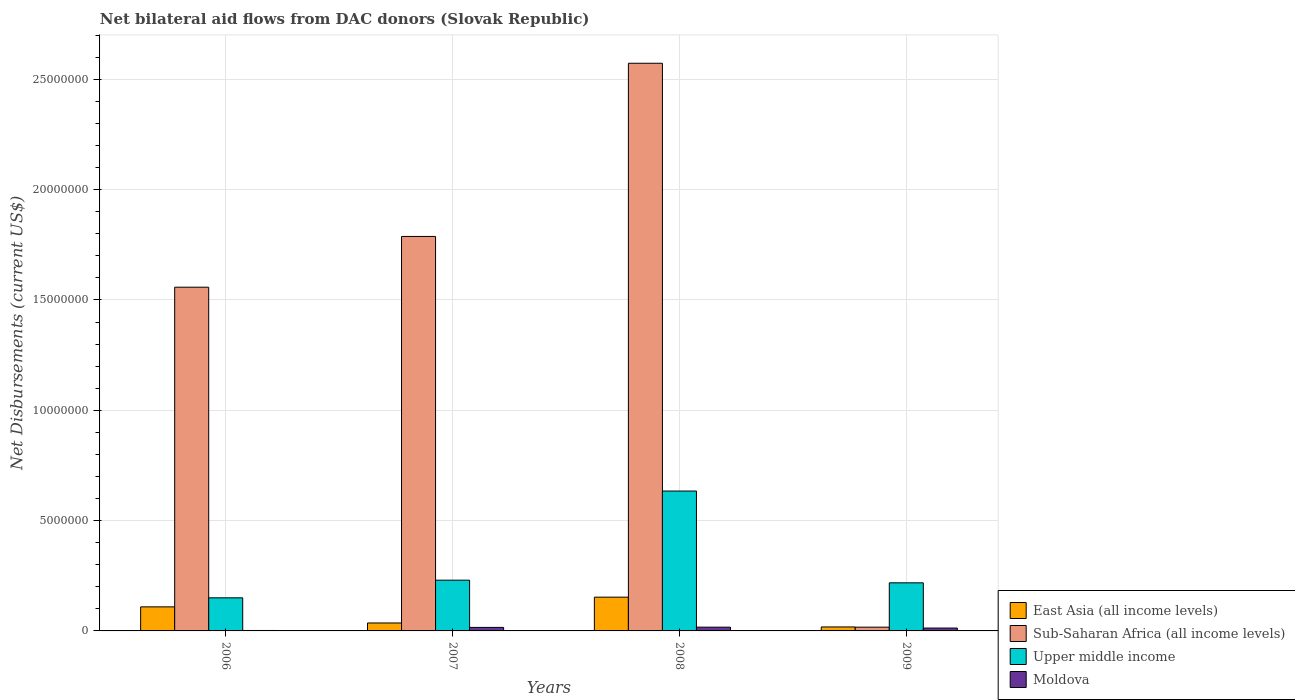How many different coloured bars are there?
Your answer should be very brief. 4. What is the label of the 2nd group of bars from the left?
Your answer should be compact. 2007. What is the net bilateral aid flows in Moldova in 2008?
Your answer should be compact. 1.70e+05. Across all years, what is the maximum net bilateral aid flows in Upper middle income?
Your response must be concise. 6.34e+06. Across all years, what is the minimum net bilateral aid flows in Sub-Saharan Africa (all income levels)?
Offer a very short reply. 1.70e+05. What is the difference between the net bilateral aid flows in Sub-Saharan Africa (all income levels) in 2006 and that in 2007?
Provide a succinct answer. -2.30e+06. What is the difference between the net bilateral aid flows in Sub-Saharan Africa (all income levels) in 2008 and the net bilateral aid flows in Upper middle income in 2006?
Offer a terse response. 2.42e+07. What is the average net bilateral aid flows in Upper middle income per year?
Keep it short and to the point. 3.08e+06. In the year 2006, what is the difference between the net bilateral aid flows in Sub-Saharan Africa (all income levels) and net bilateral aid flows in Moldova?
Provide a short and direct response. 1.56e+07. In how many years, is the net bilateral aid flows in Upper middle income greater than 23000000 US$?
Keep it short and to the point. 0. What is the ratio of the net bilateral aid flows in Upper middle income in 2006 to that in 2008?
Provide a succinct answer. 0.24. Is the net bilateral aid flows in East Asia (all income levels) in 2007 less than that in 2008?
Offer a very short reply. Yes. What is the difference between the highest and the second highest net bilateral aid flows in Upper middle income?
Your answer should be compact. 4.04e+06. What is the difference between the highest and the lowest net bilateral aid flows in Sub-Saharan Africa (all income levels)?
Your answer should be compact. 2.56e+07. In how many years, is the net bilateral aid flows in Upper middle income greater than the average net bilateral aid flows in Upper middle income taken over all years?
Your answer should be very brief. 1. Is the sum of the net bilateral aid flows in Moldova in 2007 and 2009 greater than the maximum net bilateral aid flows in Sub-Saharan Africa (all income levels) across all years?
Keep it short and to the point. No. What does the 4th bar from the left in 2006 represents?
Give a very brief answer. Moldova. What does the 1st bar from the right in 2007 represents?
Your answer should be compact. Moldova. What is the difference between two consecutive major ticks on the Y-axis?
Your answer should be very brief. 5.00e+06. Does the graph contain grids?
Your answer should be compact. Yes. How many legend labels are there?
Provide a succinct answer. 4. How are the legend labels stacked?
Ensure brevity in your answer.  Vertical. What is the title of the graph?
Offer a very short reply. Net bilateral aid flows from DAC donors (Slovak Republic). Does "Barbados" appear as one of the legend labels in the graph?
Provide a short and direct response. No. What is the label or title of the Y-axis?
Your answer should be very brief. Net Disbursements (current US$). What is the Net Disbursements (current US$) in East Asia (all income levels) in 2006?
Give a very brief answer. 1.09e+06. What is the Net Disbursements (current US$) in Sub-Saharan Africa (all income levels) in 2006?
Your answer should be compact. 1.56e+07. What is the Net Disbursements (current US$) in Upper middle income in 2006?
Ensure brevity in your answer.  1.50e+06. What is the Net Disbursements (current US$) of East Asia (all income levels) in 2007?
Your answer should be very brief. 3.60e+05. What is the Net Disbursements (current US$) in Sub-Saharan Africa (all income levels) in 2007?
Give a very brief answer. 1.79e+07. What is the Net Disbursements (current US$) of Upper middle income in 2007?
Offer a very short reply. 2.30e+06. What is the Net Disbursements (current US$) of Moldova in 2007?
Your response must be concise. 1.60e+05. What is the Net Disbursements (current US$) of East Asia (all income levels) in 2008?
Your answer should be very brief. 1.53e+06. What is the Net Disbursements (current US$) of Sub-Saharan Africa (all income levels) in 2008?
Offer a very short reply. 2.57e+07. What is the Net Disbursements (current US$) of Upper middle income in 2008?
Provide a short and direct response. 6.34e+06. What is the Net Disbursements (current US$) in Moldova in 2008?
Your answer should be very brief. 1.70e+05. What is the Net Disbursements (current US$) in Upper middle income in 2009?
Offer a terse response. 2.18e+06. What is the Net Disbursements (current US$) in Moldova in 2009?
Offer a very short reply. 1.30e+05. Across all years, what is the maximum Net Disbursements (current US$) of East Asia (all income levels)?
Provide a short and direct response. 1.53e+06. Across all years, what is the maximum Net Disbursements (current US$) in Sub-Saharan Africa (all income levels)?
Ensure brevity in your answer.  2.57e+07. Across all years, what is the maximum Net Disbursements (current US$) of Upper middle income?
Give a very brief answer. 6.34e+06. Across all years, what is the maximum Net Disbursements (current US$) in Moldova?
Provide a succinct answer. 1.70e+05. Across all years, what is the minimum Net Disbursements (current US$) in Sub-Saharan Africa (all income levels)?
Provide a succinct answer. 1.70e+05. Across all years, what is the minimum Net Disbursements (current US$) in Upper middle income?
Make the answer very short. 1.50e+06. Across all years, what is the minimum Net Disbursements (current US$) of Moldova?
Offer a terse response. 2.00e+04. What is the total Net Disbursements (current US$) in East Asia (all income levels) in the graph?
Keep it short and to the point. 3.16e+06. What is the total Net Disbursements (current US$) in Sub-Saharan Africa (all income levels) in the graph?
Give a very brief answer. 5.94e+07. What is the total Net Disbursements (current US$) in Upper middle income in the graph?
Make the answer very short. 1.23e+07. What is the difference between the Net Disbursements (current US$) in East Asia (all income levels) in 2006 and that in 2007?
Your answer should be very brief. 7.30e+05. What is the difference between the Net Disbursements (current US$) of Sub-Saharan Africa (all income levels) in 2006 and that in 2007?
Provide a succinct answer. -2.30e+06. What is the difference between the Net Disbursements (current US$) in Upper middle income in 2006 and that in 2007?
Provide a succinct answer. -8.00e+05. What is the difference between the Net Disbursements (current US$) in East Asia (all income levels) in 2006 and that in 2008?
Your answer should be very brief. -4.40e+05. What is the difference between the Net Disbursements (current US$) in Sub-Saharan Africa (all income levels) in 2006 and that in 2008?
Provide a short and direct response. -1.02e+07. What is the difference between the Net Disbursements (current US$) of Upper middle income in 2006 and that in 2008?
Provide a succinct answer. -4.84e+06. What is the difference between the Net Disbursements (current US$) in East Asia (all income levels) in 2006 and that in 2009?
Your response must be concise. 9.10e+05. What is the difference between the Net Disbursements (current US$) of Sub-Saharan Africa (all income levels) in 2006 and that in 2009?
Ensure brevity in your answer.  1.54e+07. What is the difference between the Net Disbursements (current US$) in Upper middle income in 2006 and that in 2009?
Offer a terse response. -6.80e+05. What is the difference between the Net Disbursements (current US$) in East Asia (all income levels) in 2007 and that in 2008?
Keep it short and to the point. -1.17e+06. What is the difference between the Net Disbursements (current US$) in Sub-Saharan Africa (all income levels) in 2007 and that in 2008?
Make the answer very short. -7.85e+06. What is the difference between the Net Disbursements (current US$) of Upper middle income in 2007 and that in 2008?
Provide a succinct answer. -4.04e+06. What is the difference between the Net Disbursements (current US$) in East Asia (all income levels) in 2007 and that in 2009?
Provide a succinct answer. 1.80e+05. What is the difference between the Net Disbursements (current US$) in Sub-Saharan Africa (all income levels) in 2007 and that in 2009?
Offer a terse response. 1.77e+07. What is the difference between the Net Disbursements (current US$) of Upper middle income in 2007 and that in 2009?
Your answer should be compact. 1.20e+05. What is the difference between the Net Disbursements (current US$) of East Asia (all income levels) in 2008 and that in 2009?
Keep it short and to the point. 1.35e+06. What is the difference between the Net Disbursements (current US$) of Sub-Saharan Africa (all income levels) in 2008 and that in 2009?
Give a very brief answer. 2.56e+07. What is the difference between the Net Disbursements (current US$) of Upper middle income in 2008 and that in 2009?
Make the answer very short. 4.16e+06. What is the difference between the Net Disbursements (current US$) of Moldova in 2008 and that in 2009?
Provide a short and direct response. 4.00e+04. What is the difference between the Net Disbursements (current US$) of East Asia (all income levels) in 2006 and the Net Disbursements (current US$) of Sub-Saharan Africa (all income levels) in 2007?
Provide a short and direct response. -1.68e+07. What is the difference between the Net Disbursements (current US$) of East Asia (all income levels) in 2006 and the Net Disbursements (current US$) of Upper middle income in 2007?
Give a very brief answer. -1.21e+06. What is the difference between the Net Disbursements (current US$) of East Asia (all income levels) in 2006 and the Net Disbursements (current US$) of Moldova in 2007?
Ensure brevity in your answer.  9.30e+05. What is the difference between the Net Disbursements (current US$) in Sub-Saharan Africa (all income levels) in 2006 and the Net Disbursements (current US$) in Upper middle income in 2007?
Your answer should be very brief. 1.33e+07. What is the difference between the Net Disbursements (current US$) of Sub-Saharan Africa (all income levels) in 2006 and the Net Disbursements (current US$) of Moldova in 2007?
Keep it short and to the point. 1.54e+07. What is the difference between the Net Disbursements (current US$) in Upper middle income in 2006 and the Net Disbursements (current US$) in Moldova in 2007?
Your response must be concise. 1.34e+06. What is the difference between the Net Disbursements (current US$) of East Asia (all income levels) in 2006 and the Net Disbursements (current US$) of Sub-Saharan Africa (all income levels) in 2008?
Your response must be concise. -2.46e+07. What is the difference between the Net Disbursements (current US$) of East Asia (all income levels) in 2006 and the Net Disbursements (current US$) of Upper middle income in 2008?
Ensure brevity in your answer.  -5.25e+06. What is the difference between the Net Disbursements (current US$) in East Asia (all income levels) in 2006 and the Net Disbursements (current US$) in Moldova in 2008?
Provide a short and direct response. 9.20e+05. What is the difference between the Net Disbursements (current US$) of Sub-Saharan Africa (all income levels) in 2006 and the Net Disbursements (current US$) of Upper middle income in 2008?
Provide a short and direct response. 9.24e+06. What is the difference between the Net Disbursements (current US$) of Sub-Saharan Africa (all income levels) in 2006 and the Net Disbursements (current US$) of Moldova in 2008?
Your response must be concise. 1.54e+07. What is the difference between the Net Disbursements (current US$) of Upper middle income in 2006 and the Net Disbursements (current US$) of Moldova in 2008?
Provide a short and direct response. 1.33e+06. What is the difference between the Net Disbursements (current US$) of East Asia (all income levels) in 2006 and the Net Disbursements (current US$) of Sub-Saharan Africa (all income levels) in 2009?
Your response must be concise. 9.20e+05. What is the difference between the Net Disbursements (current US$) in East Asia (all income levels) in 2006 and the Net Disbursements (current US$) in Upper middle income in 2009?
Make the answer very short. -1.09e+06. What is the difference between the Net Disbursements (current US$) of East Asia (all income levels) in 2006 and the Net Disbursements (current US$) of Moldova in 2009?
Your response must be concise. 9.60e+05. What is the difference between the Net Disbursements (current US$) of Sub-Saharan Africa (all income levels) in 2006 and the Net Disbursements (current US$) of Upper middle income in 2009?
Provide a short and direct response. 1.34e+07. What is the difference between the Net Disbursements (current US$) in Sub-Saharan Africa (all income levels) in 2006 and the Net Disbursements (current US$) in Moldova in 2009?
Your answer should be compact. 1.54e+07. What is the difference between the Net Disbursements (current US$) of Upper middle income in 2006 and the Net Disbursements (current US$) of Moldova in 2009?
Provide a succinct answer. 1.37e+06. What is the difference between the Net Disbursements (current US$) of East Asia (all income levels) in 2007 and the Net Disbursements (current US$) of Sub-Saharan Africa (all income levels) in 2008?
Offer a very short reply. -2.54e+07. What is the difference between the Net Disbursements (current US$) of East Asia (all income levels) in 2007 and the Net Disbursements (current US$) of Upper middle income in 2008?
Offer a very short reply. -5.98e+06. What is the difference between the Net Disbursements (current US$) of Sub-Saharan Africa (all income levels) in 2007 and the Net Disbursements (current US$) of Upper middle income in 2008?
Your answer should be very brief. 1.15e+07. What is the difference between the Net Disbursements (current US$) in Sub-Saharan Africa (all income levels) in 2007 and the Net Disbursements (current US$) in Moldova in 2008?
Your answer should be compact. 1.77e+07. What is the difference between the Net Disbursements (current US$) of Upper middle income in 2007 and the Net Disbursements (current US$) of Moldova in 2008?
Provide a succinct answer. 2.13e+06. What is the difference between the Net Disbursements (current US$) of East Asia (all income levels) in 2007 and the Net Disbursements (current US$) of Sub-Saharan Africa (all income levels) in 2009?
Your response must be concise. 1.90e+05. What is the difference between the Net Disbursements (current US$) of East Asia (all income levels) in 2007 and the Net Disbursements (current US$) of Upper middle income in 2009?
Keep it short and to the point. -1.82e+06. What is the difference between the Net Disbursements (current US$) in East Asia (all income levels) in 2007 and the Net Disbursements (current US$) in Moldova in 2009?
Offer a very short reply. 2.30e+05. What is the difference between the Net Disbursements (current US$) in Sub-Saharan Africa (all income levels) in 2007 and the Net Disbursements (current US$) in Upper middle income in 2009?
Provide a short and direct response. 1.57e+07. What is the difference between the Net Disbursements (current US$) of Sub-Saharan Africa (all income levels) in 2007 and the Net Disbursements (current US$) of Moldova in 2009?
Offer a very short reply. 1.78e+07. What is the difference between the Net Disbursements (current US$) in Upper middle income in 2007 and the Net Disbursements (current US$) in Moldova in 2009?
Ensure brevity in your answer.  2.17e+06. What is the difference between the Net Disbursements (current US$) of East Asia (all income levels) in 2008 and the Net Disbursements (current US$) of Sub-Saharan Africa (all income levels) in 2009?
Ensure brevity in your answer.  1.36e+06. What is the difference between the Net Disbursements (current US$) in East Asia (all income levels) in 2008 and the Net Disbursements (current US$) in Upper middle income in 2009?
Provide a succinct answer. -6.50e+05. What is the difference between the Net Disbursements (current US$) in East Asia (all income levels) in 2008 and the Net Disbursements (current US$) in Moldova in 2009?
Make the answer very short. 1.40e+06. What is the difference between the Net Disbursements (current US$) in Sub-Saharan Africa (all income levels) in 2008 and the Net Disbursements (current US$) in Upper middle income in 2009?
Provide a short and direct response. 2.36e+07. What is the difference between the Net Disbursements (current US$) in Sub-Saharan Africa (all income levels) in 2008 and the Net Disbursements (current US$) in Moldova in 2009?
Provide a succinct answer. 2.56e+07. What is the difference between the Net Disbursements (current US$) in Upper middle income in 2008 and the Net Disbursements (current US$) in Moldova in 2009?
Your answer should be very brief. 6.21e+06. What is the average Net Disbursements (current US$) of East Asia (all income levels) per year?
Your answer should be compact. 7.90e+05. What is the average Net Disbursements (current US$) of Sub-Saharan Africa (all income levels) per year?
Provide a short and direct response. 1.48e+07. What is the average Net Disbursements (current US$) of Upper middle income per year?
Ensure brevity in your answer.  3.08e+06. In the year 2006, what is the difference between the Net Disbursements (current US$) in East Asia (all income levels) and Net Disbursements (current US$) in Sub-Saharan Africa (all income levels)?
Ensure brevity in your answer.  -1.45e+07. In the year 2006, what is the difference between the Net Disbursements (current US$) of East Asia (all income levels) and Net Disbursements (current US$) of Upper middle income?
Provide a short and direct response. -4.10e+05. In the year 2006, what is the difference between the Net Disbursements (current US$) of East Asia (all income levels) and Net Disbursements (current US$) of Moldova?
Offer a terse response. 1.07e+06. In the year 2006, what is the difference between the Net Disbursements (current US$) in Sub-Saharan Africa (all income levels) and Net Disbursements (current US$) in Upper middle income?
Provide a succinct answer. 1.41e+07. In the year 2006, what is the difference between the Net Disbursements (current US$) in Sub-Saharan Africa (all income levels) and Net Disbursements (current US$) in Moldova?
Provide a succinct answer. 1.56e+07. In the year 2006, what is the difference between the Net Disbursements (current US$) of Upper middle income and Net Disbursements (current US$) of Moldova?
Offer a terse response. 1.48e+06. In the year 2007, what is the difference between the Net Disbursements (current US$) of East Asia (all income levels) and Net Disbursements (current US$) of Sub-Saharan Africa (all income levels)?
Give a very brief answer. -1.75e+07. In the year 2007, what is the difference between the Net Disbursements (current US$) of East Asia (all income levels) and Net Disbursements (current US$) of Upper middle income?
Provide a short and direct response. -1.94e+06. In the year 2007, what is the difference between the Net Disbursements (current US$) of East Asia (all income levels) and Net Disbursements (current US$) of Moldova?
Your response must be concise. 2.00e+05. In the year 2007, what is the difference between the Net Disbursements (current US$) of Sub-Saharan Africa (all income levels) and Net Disbursements (current US$) of Upper middle income?
Your response must be concise. 1.56e+07. In the year 2007, what is the difference between the Net Disbursements (current US$) of Sub-Saharan Africa (all income levels) and Net Disbursements (current US$) of Moldova?
Your response must be concise. 1.77e+07. In the year 2007, what is the difference between the Net Disbursements (current US$) of Upper middle income and Net Disbursements (current US$) of Moldova?
Give a very brief answer. 2.14e+06. In the year 2008, what is the difference between the Net Disbursements (current US$) of East Asia (all income levels) and Net Disbursements (current US$) of Sub-Saharan Africa (all income levels)?
Ensure brevity in your answer.  -2.42e+07. In the year 2008, what is the difference between the Net Disbursements (current US$) in East Asia (all income levels) and Net Disbursements (current US$) in Upper middle income?
Provide a succinct answer. -4.81e+06. In the year 2008, what is the difference between the Net Disbursements (current US$) of East Asia (all income levels) and Net Disbursements (current US$) of Moldova?
Offer a terse response. 1.36e+06. In the year 2008, what is the difference between the Net Disbursements (current US$) of Sub-Saharan Africa (all income levels) and Net Disbursements (current US$) of Upper middle income?
Provide a succinct answer. 1.94e+07. In the year 2008, what is the difference between the Net Disbursements (current US$) in Sub-Saharan Africa (all income levels) and Net Disbursements (current US$) in Moldova?
Your answer should be very brief. 2.56e+07. In the year 2008, what is the difference between the Net Disbursements (current US$) in Upper middle income and Net Disbursements (current US$) in Moldova?
Provide a short and direct response. 6.17e+06. In the year 2009, what is the difference between the Net Disbursements (current US$) in Sub-Saharan Africa (all income levels) and Net Disbursements (current US$) in Upper middle income?
Ensure brevity in your answer.  -2.01e+06. In the year 2009, what is the difference between the Net Disbursements (current US$) of Sub-Saharan Africa (all income levels) and Net Disbursements (current US$) of Moldova?
Your response must be concise. 4.00e+04. In the year 2009, what is the difference between the Net Disbursements (current US$) in Upper middle income and Net Disbursements (current US$) in Moldova?
Provide a short and direct response. 2.05e+06. What is the ratio of the Net Disbursements (current US$) in East Asia (all income levels) in 2006 to that in 2007?
Keep it short and to the point. 3.03. What is the ratio of the Net Disbursements (current US$) in Sub-Saharan Africa (all income levels) in 2006 to that in 2007?
Ensure brevity in your answer.  0.87. What is the ratio of the Net Disbursements (current US$) in Upper middle income in 2006 to that in 2007?
Offer a terse response. 0.65. What is the ratio of the Net Disbursements (current US$) of East Asia (all income levels) in 2006 to that in 2008?
Provide a succinct answer. 0.71. What is the ratio of the Net Disbursements (current US$) in Sub-Saharan Africa (all income levels) in 2006 to that in 2008?
Ensure brevity in your answer.  0.61. What is the ratio of the Net Disbursements (current US$) of Upper middle income in 2006 to that in 2008?
Make the answer very short. 0.24. What is the ratio of the Net Disbursements (current US$) in Moldova in 2006 to that in 2008?
Offer a terse response. 0.12. What is the ratio of the Net Disbursements (current US$) of East Asia (all income levels) in 2006 to that in 2009?
Offer a terse response. 6.06. What is the ratio of the Net Disbursements (current US$) in Sub-Saharan Africa (all income levels) in 2006 to that in 2009?
Make the answer very short. 91.65. What is the ratio of the Net Disbursements (current US$) in Upper middle income in 2006 to that in 2009?
Your response must be concise. 0.69. What is the ratio of the Net Disbursements (current US$) in Moldova in 2006 to that in 2009?
Offer a terse response. 0.15. What is the ratio of the Net Disbursements (current US$) of East Asia (all income levels) in 2007 to that in 2008?
Your answer should be compact. 0.24. What is the ratio of the Net Disbursements (current US$) of Sub-Saharan Africa (all income levels) in 2007 to that in 2008?
Your response must be concise. 0.69. What is the ratio of the Net Disbursements (current US$) of Upper middle income in 2007 to that in 2008?
Provide a succinct answer. 0.36. What is the ratio of the Net Disbursements (current US$) of Moldova in 2007 to that in 2008?
Offer a very short reply. 0.94. What is the ratio of the Net Disbursements (current US$) of East Asia (all income levels) in 2007 to that in 2009?
Your answer should be very brief. 2. What is the ratio of the Net Disbursements (current US$) of Sub-Saharan Africa (all income levels) in 2007 to that in 2009?
Your answer should be compact. 105.18. What is the ratio of the Net Disbursements (current US$) in Upper middle income in 2007 to that in 2009?
Ensure brevity in your answer.  1.05. What is the ratio of the Net Disbursements (current US$) of Moldova in 2007 to that in 2009?
Give a very brief answer. 1.23. What is the ratio of the Net Disbursements (current US$) in East Asia (all income levels) in 2008 to that in 2009?
Make the answer very short. 8.5. What is the ratio of the Net Disbursements (current US$) of Sub-Saharan Africa (all income levels) in 2008 to that in 2009?
Your answer should be compact. 151.35. What is the ratio of the Net Disbursements (current US$) in Upper middle income in 2008 to that in 2009?
Give a very brief answer. 2.91. What is the ratio of the Net Disbursements (current US$) of Moldova in 2008 to that in 2009?
Your answer should be compact. 1.31. What is the difference between the highest and the second highest Net Disbursements (current US$) of East Asia (all income levels)?
Keep it short and to the point. 4.40e+05. What is the difference between the highest and the second highest Net Disbursements (current US$) of Sub-Saharan Africa (all income levels)?
Offer a terse response. 7.85e+06. What is the difference between the highest and the second highest Net Disbursements (current US$) in Upper middle income?
Offer a terse response. 4.04e+06. What is the difference between the highest and the second highest Net Disbursements (current US$) in Moldova?
Make the answer very short. 10000. What is the difference between the highest and the lowest Net Disbursements (current US$) of East Asia (all income levels)?
Ensure brevity in your answer.  1.35e+06. What is the difference between the highest and the lowest Net Disbursements (current US$) of Sub-Saharan Africa (all income levels)?
Keep it short and to the point. 2.56e+07. What is the difference between the highest and the lowest Net Disbursements (current US$) of Upper middle income?
Your response must be concise. 4.84e+06. 